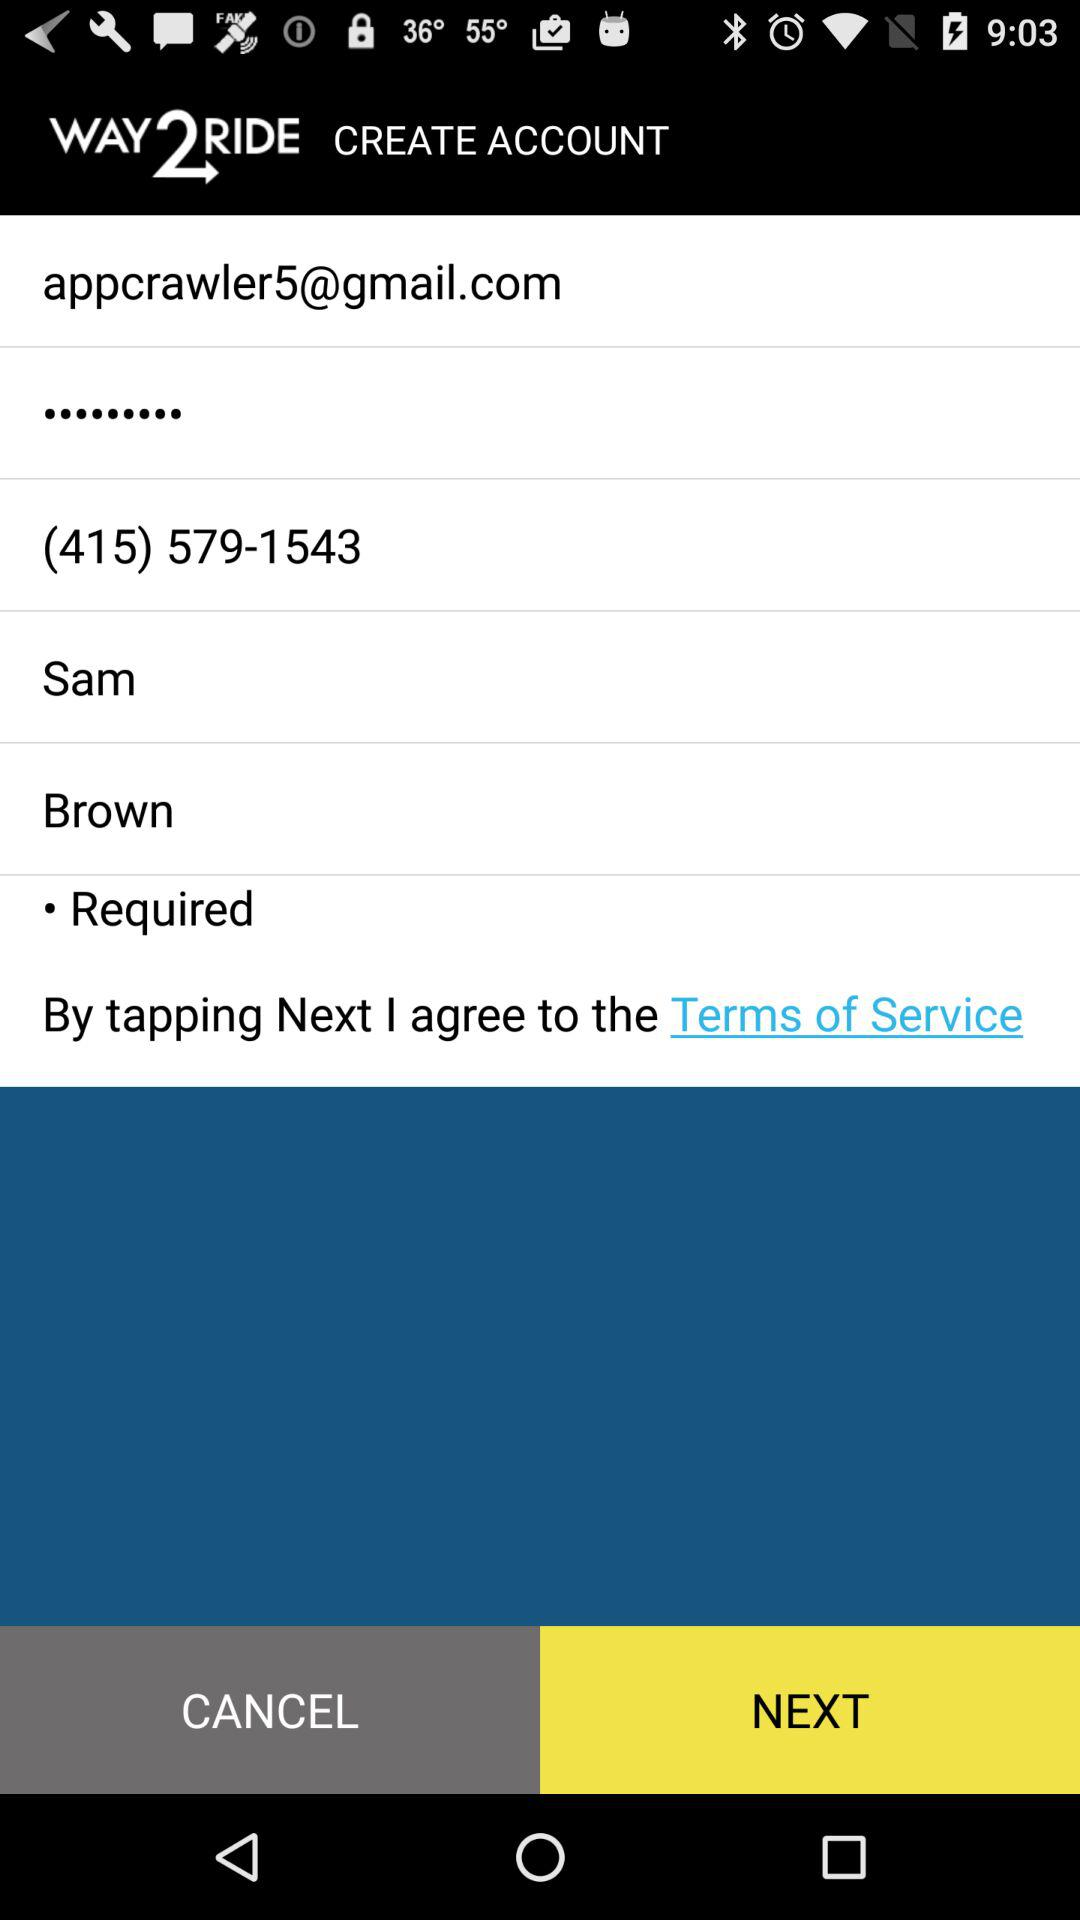What is the name of the application? The name of the application is "WAY2RIDE". 